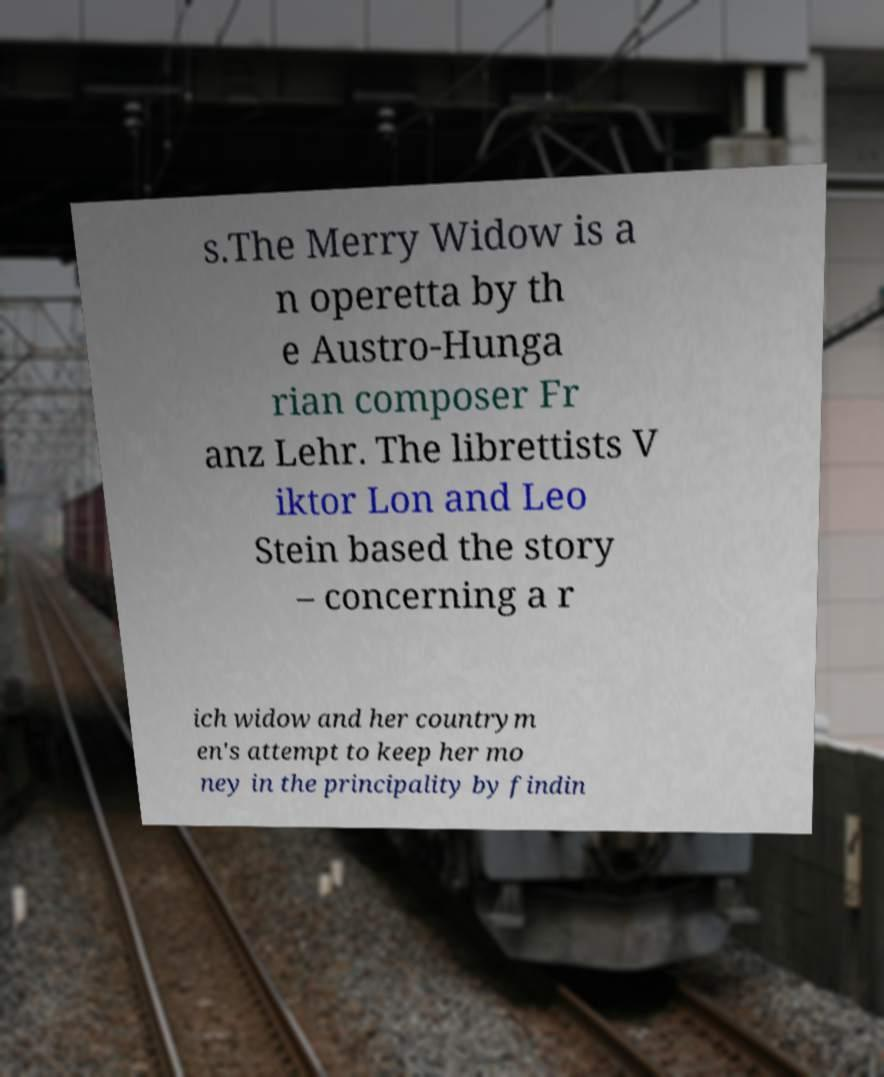There's text embedded in this image that I need extracted. Can you transcribe it verbatim? s.The Merry Widow is a n operetta by th e Austro-Hunga rian composer Fr anz Lehr. The librettists V iktor Lon and Leo Stein based the story – concerning a r ich widow and her countrym en's attempt to keep her mo ney in the principality by findin 